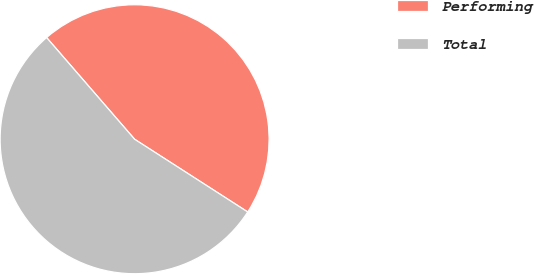Convert chart to OTSL. <chart><loc_0><loc_0><loc_500><loc_500><pie_chart><fcel>Performing<fcel>Total<nl><fcel>45.45%<fcel>54.55%<nl></chart> 